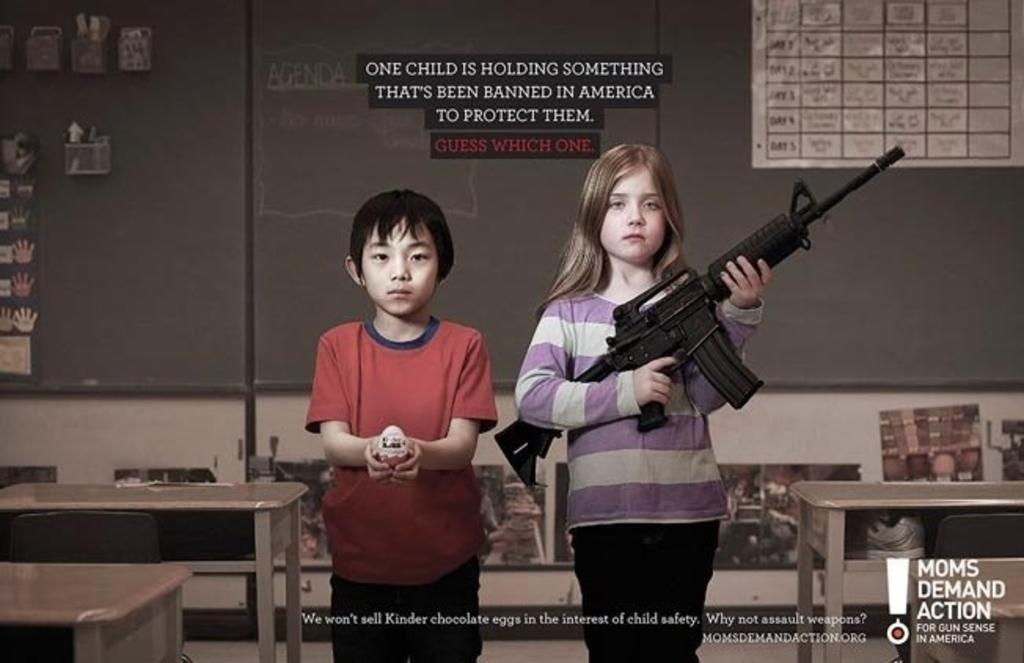How many people are in the image? There are people in the image, but the exact number is not specified. What are the people doing in the image? The people are standing in the image. What objects are the people holding in their hands? The people are holding rifles in their hands. How many cherries can be seen on the horses in the image? There are no horses or cherries present in the image. What type of cart is being pulled by the people in the image? There is no cart present in the image. 